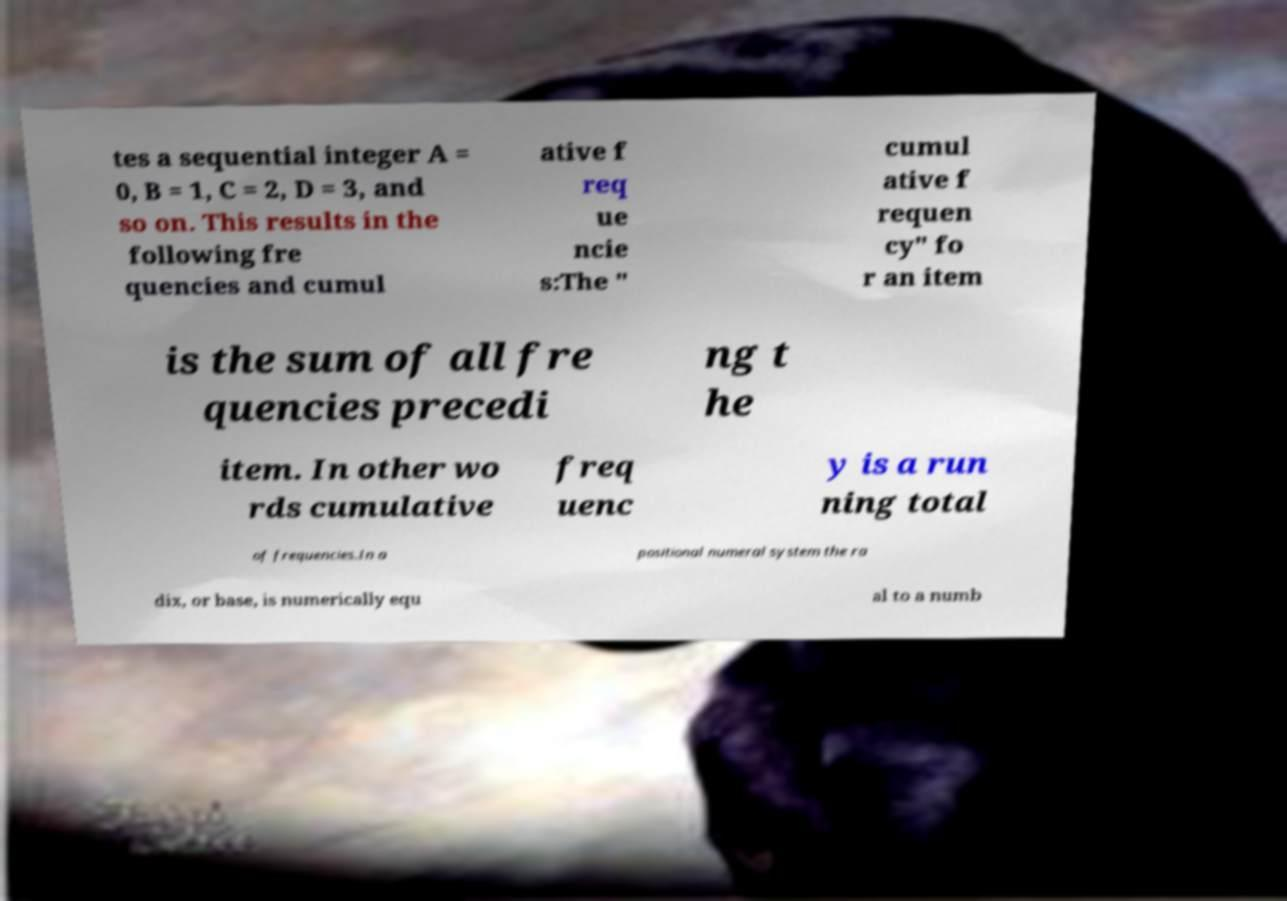Could you extract and type out the text from this image? tes a sequential integer A = 0, B = 1, C = 2, D = 3, and so on. This results in the following fre quencies and cumul ative f req ue ncie s:The " cumul ative f requen cy" fo r an item is the sum of all fre quencies precedi ng t he item. In other wo rds cumulative freq uenc y is a run ning total of frequencies.In a positional numeral system the ra dix, or base, is numerically equ al to a numb 